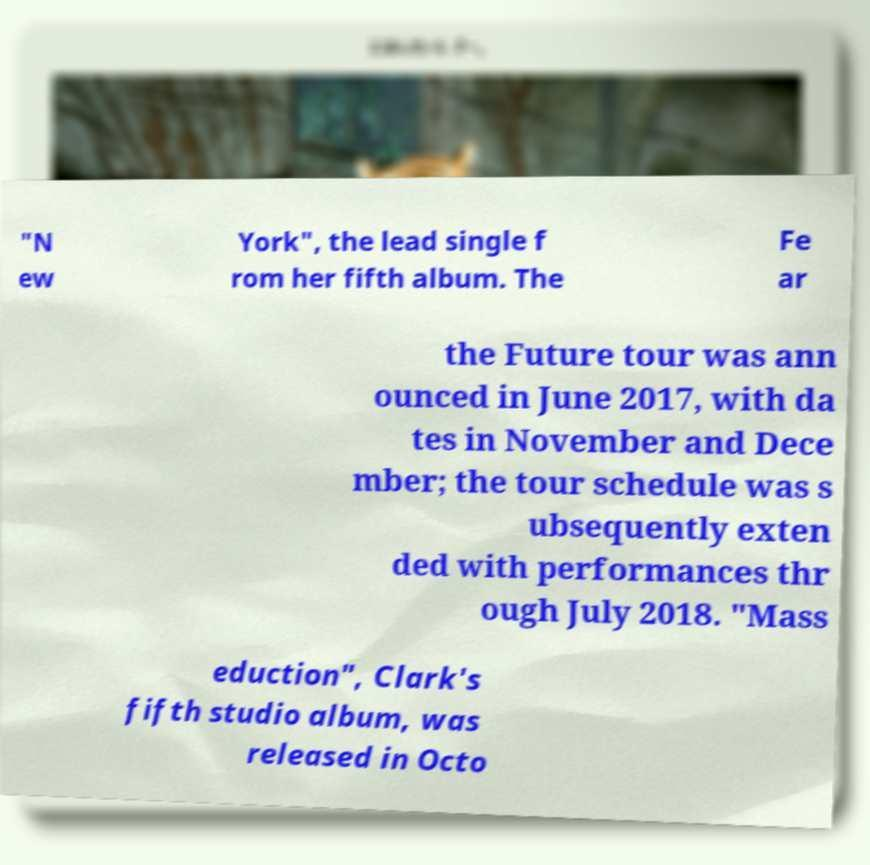There's text embedded in this image that I need extracted. Can you transcribe it verbatim? "N ew York", the lead single f rom her fifth album. The Fe ar the Future tour was ann ounced in June 2017, with da tes in November and Dece mber; the tour schedule was s ubsequently exten ded with performances thr ough July 2018. "Mass eduction", Clark's fifth studio album, was released in Octo 